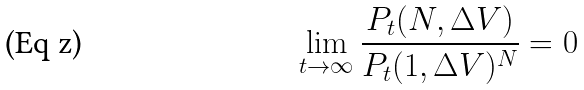Convert formula to latex. <formula><loc_0><loc_0><loc_500><loc_500>\lim _ { t \rightarrow \infty } \frac { P _ { t } ( N , \Delta V ) } { P _ { t } ( 1 , \Delta V ) ^ { N } } = 0</formula> 